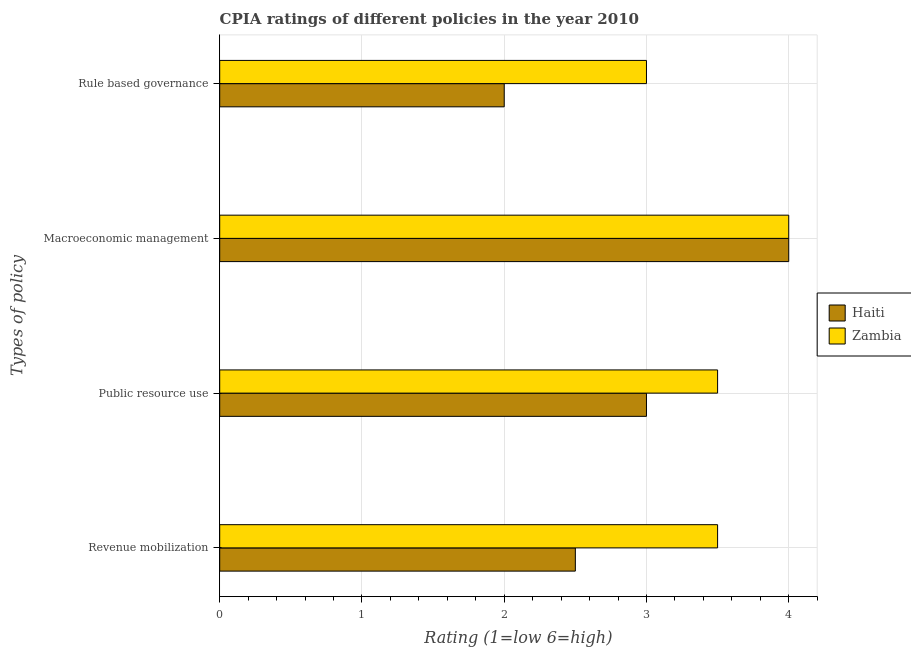Are the number of bars on each tick of the Y-axis equal?
Your answer should be very brief. Yes. How many bars are there on the 4th tick from the top?
Offer a terse response. 2. What is the label of the 2nd group of bars from the top?
Offer a terse response. Macroeconomic management. What is the cpia rating of rule based governance in Zambia?
Provide a succinct answer. 3. Across all countries, what is the maximum cpia rating of macroeconomic management?
Offer a very short reply. 4. Across all countries, what is the minimum cpia rating of revenue mobilization?
Your response must be concise. 2.5. In which country was the cpia rating of macroeconomic management maximum?
Offer a terse response. Haiti. In which country was the cpia rating of macroeconomic management minimum?
Provide a short and direct response. Haiti. What is the total cpia rating of public resource use in the graph?
Make the answer very short. 6.5. What is the difference between the cpia rating of public resource use and cpia rating of revenue mobilization in Zambia?
Offer a very short reply. 0. What is the ratio of the cpia rating of revenue mobilization in Haiti to that in Zambia?
Provide a succinct answer. 0.71. Is the cpia rating of public resource use in Haiti less than that in Zambia?
Your answer should be compact. Yes. Is the difference between the cpia rating of rule based governance in Haiti and Zambia greater than the difference between the cpia rating of macroeconomic management in Haiti and Zambia?
Offer a terse response. No. Is it the case that in every country, the sum of the cpia rating of revenue mobilization and cpia rating of macroeconomic management is greater than the sum of cpia rating of public resource use and cpia rating of rule based governance?
Make the answer very short. No. What does the 1st bar from the top in Public resource use represents?
Give a very brief answer. Zambia. What does the 1st bar from the bottom in Public resource use represents?
Provide a short and direct response. Haiti. Is it the case that in every country, the sum of the cpia rating of revenue mobilization and cpia rating of public resource use is greater than the cpia rating of macroeconomic management?
Make the answer very short. Yes. How many bars are there?
Ensure brevity in your answer.  8. Are the values on the major ticks of X-axis written in scientific E-notation?
Offer a terse response. No. Where does the legend appear in the graph?
Your answer should be very brief. Center right. How are the legend labels stacked?
Your response must be concise. Vertical. What is the title of the graph?
Provide a short and direct response. CPIA ratings of different policies in the year 2010. Does "Channel Islands" appear as one of the legend labels in the graph?
Offer a terse response. No. What is the label or title of the X-axis?
Keep it short and to the point. Rating (1=low 6=high). What is the label or title of the Y-axis?
Make the answer very short. Types of policy. What is the Rating (1=low 6=high) of Haiti in Macroeconomic management?
Your answer should be very brief. 4. What is the Rating (1=low 6=high) of Haiti in Rule based governance?
Ensure brevity in your answer.  2. Across all Types of policy, what is the maximum Rating (1=low 6=high) of Haiti?
Your answer should be very brief. 4. Across all Types of policy, what is the maximum Rating (1=low 6=high) in Zambia?
Provide a short and direct response. 4. Across all Types of policy, what is the minimum Rating (1=low 6=high) in Haiti?
Keep it short and to the point. 2. Across all Types of policy, what is the minimum Rating (1=low 6=high) of Zambia?
Ensure brevity in your answer.  3. What is the total Rating (1=low 6=high) in Haiti in the graph?
Ensure brevity in your answer.  11.5. What is the difference between the Rating (1=low 6=high) in Haiti in Revenue mobilization and that in Macroeconomic management?
Provide a succinct answer. -1.5. What is the difference between the Rating (1=low 6=high) of Haiti in Public resource use and that in Macroeconomic management?
Give a very brief answer. -1. What is the difference between the Rating (1=low 6=high) in Zambia in Public resource use and that in Macroeconomic management?
Make the answer very short. -0.5. What is the difference between the Rating (1=low 6=high) of Zambia in Public resource use and that in Rule based governance?
Offer a terse response. 0.5. What is the difference between the Rating (1=low 6=high) of Haiti in Macroeconomic management and that in Rule based governance?
Provide a succinct answer. 2. What is the difference between the Rating (1=low 6=high) in Haiti in Revenue mobilization and the Rating (1=low 6=high) in Zambia in Public resource use?
Ensure brevity in your answer.  -1. What is the difference between the Rating (1=low 6=high) of Haiti in Revenue mobilization and the Rating (1=low 6=high) of Zambia in Macroeconomic management?
Your answer should be compact. -1.5. What is the difference between the Rating (1=low 6=high) in Haiti in Revenue mobilization and the Rating (1=low 6=high) in Zambia in Rule based governance?
Offer a very short reply. -0.5. What is the difference between the Rating (1=low 6=high) of Haiti in Public resource use and the Rating (1=low 6=high) of Zambia in Rule based governance?
Your response must be concise. 0. What is the difference between the Rating (1=low 6=high) in Haiti in Macroeconomic management and the Rating (1=low 6=high) in Zambia in Rule based governance?
Make the answer very short. 1. What is the average Rating (1=low 6=high) in Haiti per Types of policy?
Give a very brief answer. 2.88. What is the difference between the Rating (1=low 6=high) of Haiti and Rating (1=low 6=high) of Zambia in Public resource use?
Your answer should be compact. -0.5. What is the difference between the Rating (1=low 6=high) of Haiti and Rating (1=low 6=high) of Zambia in Macroeconomic management?
Your answer should be very brief. 0. What is the difference between the Rating (1=low 6=high) in Haiti and Rating (1=low 6=high) in Zambia in Rule based governance?
Your answer should be compact. -1. What is the ratio of the Rating (1=low 6=high) of Haiti in Revenue mobilization to that in Public resource use?
Make the answer very short. 0.83. What is the ratio of the Rating (1=low 6=high) of Zambia in Revenue mobilization to that in Public resource use?
Offer a terse response. 1. What is the ratio of the Rating (1=low 6=high) in Haiti in Revenue mobilization to that in Macroeconomic management?
Offer a very short reply. 0.62. What is the ratio of the Rating (1=low 6=high) of Zambia in Revenue mobilization to that in Macroeconomic management?
Make the answer very short. 0.88. What is the ratio of the Rating (1=low 6=high) in Haiti in Revenue mobilization to that in Rule based governance?
Keep it short and to the point. 1.25. What is the ratio of the Rating (1=low 6=high) of Zambia in Revenue mobilization to that in Rule based governance?
Provide a succinct answer. 1.17. What is the ratio of the Rating (1=low 6=high) of Haiti in Public resource use to that in Macroeconomic management?
Make the answer very short. 0.75. What is the ratio of the Rating (1=low 6=high) in Zambia in Public resource use to that in Macroeconomic management?
Ensure brevity in your answer.  0.88. What is the ratio of the Rating (1=low 6=high) in Zambia in Macroeconomic management to that in Rule based governance?
Keep it short and to the point. 1.33. 